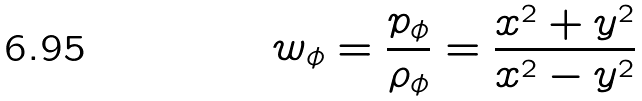<formula> <loc_0><loc_0><loc_500><loc_500>w _ { \phi } = \frac { p _ { \phi } } { \rho _ { \phi } } = \frac { x ^ { 2 } + y ^ { 2 } } { x ^ { 2 } - y ^ { 2 } }</formula> 